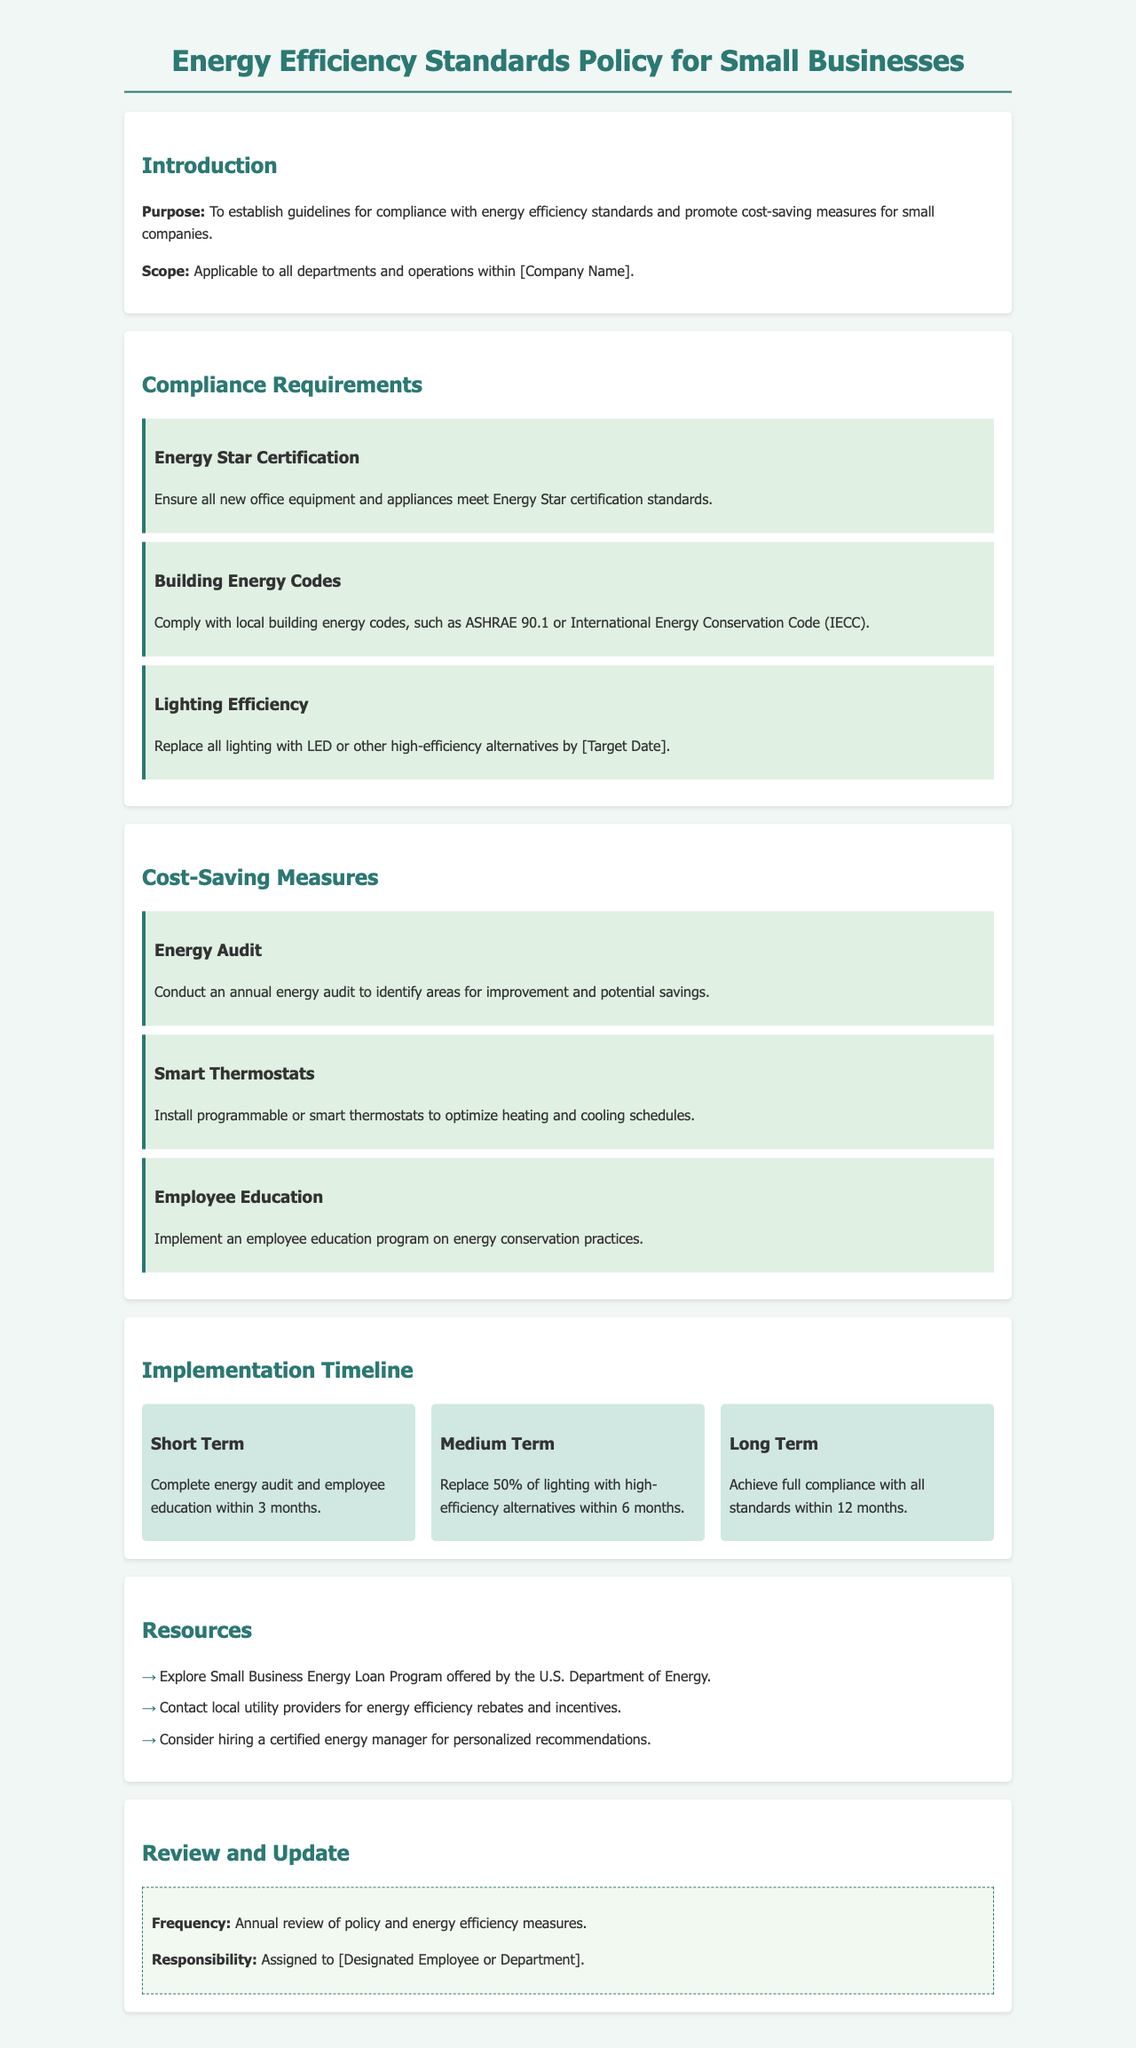what is the purpose of the document? The purpose establishes guidelines for compliance with energy efficiency standards and promotes cost-saving measures for small companies.
Answer: To establish guidelines for compliance with energy efficiency standards and promote cost-saving measures for small companies what is required for Energy Star Certification? The requirement specifies that all new office equipment and appliances must meet Energy Star certification standards.
Answer: Ensure all new office equipment and appliances meet Energy Star certification standards when should all lighting be replaced? The document mentions replacing all lighting by a specified date, indicated as [Target Date].
Answer: [Target Date] what is a recommended cost-saving measure involving technology? The document suggests installing programmable or smart thermostats to optimize heating and cooling schedules.
Answer: Install programmable or smart thermostats what percentage of lighting should be replaced within the medium term? The document states that 50% of lighting should be replaced with high-efficiency alternatives within 6 months.
Answer: 50% what is the frequency for reviewing the policy? The policy is set to be reviewed annually according to the document.
Answer: Annual which department is responsible for the review of the policy? The responsibility for the review is assigned to a designated employee or department, mentioned as [Designated Employee or Department].
Answer: [Designated Employee or Department] what is the timeline for completing the energy audit? The document mentions that the energy audit should be completed within 3 months.
Answer: 3 months 